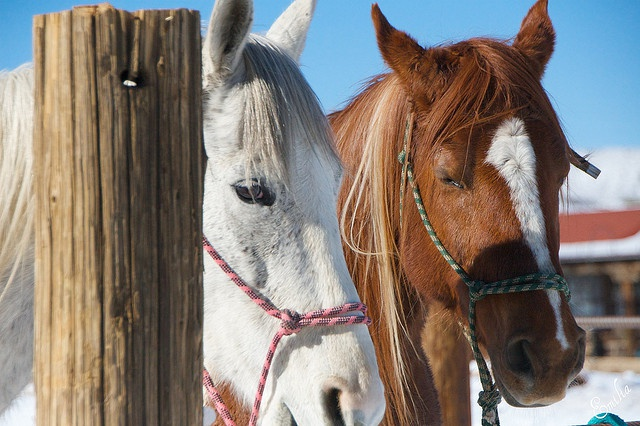Describe the objects in this image and their specific colors. I can see horse in gray, black, maroon, and brown tones and horse in gray, lightgray, and darkgray tones in this image. 